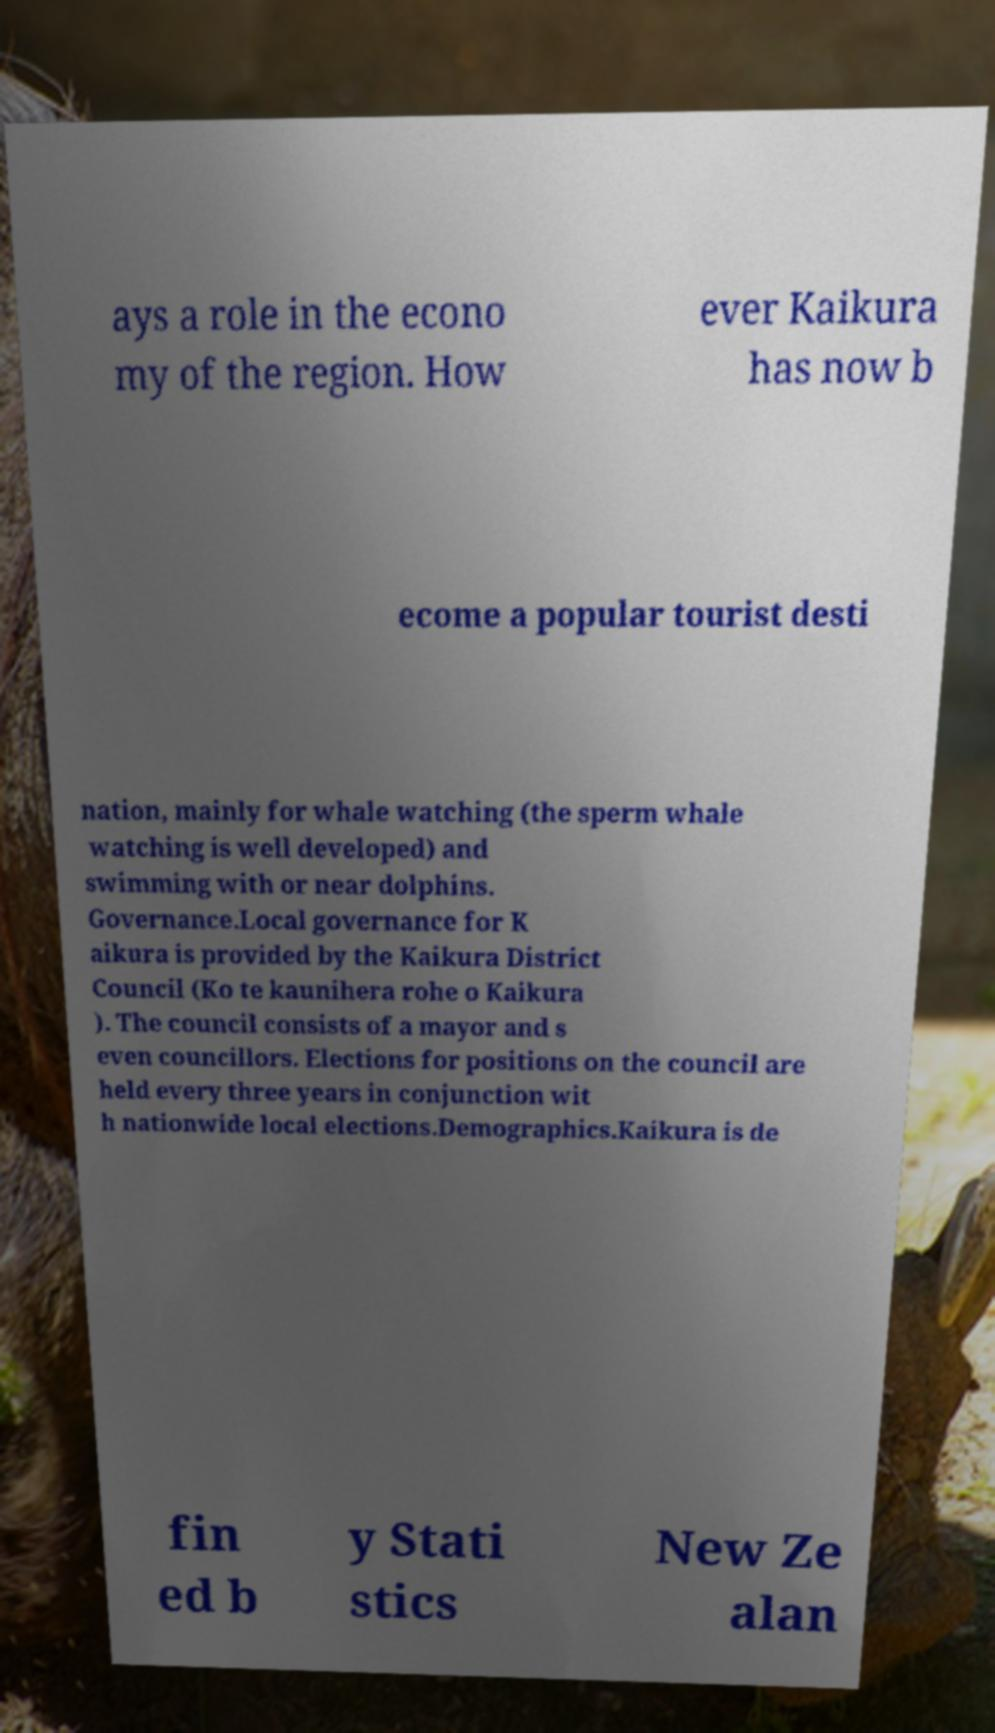Could you assist in decoding the text presented in this image and type it out clearly? ays a role in the econo my of the region. How ever Kaikura has now b ecome a popular tourist desti nation, mainly for whale watching (the sperm whale watching is well developed) and swimming with or near dolphins. Governance.Local governance for K aikura is provided by the Kaikura District Council (Ko te kaunihera rohe o Kaikura ). The council consists of a mayor and s even councillors. Elections for positions on the council are held every three years in conjunction wit h nationwide local elections.Demographics.Kaikura is de fin ed b y Stati stics New Ze alan 